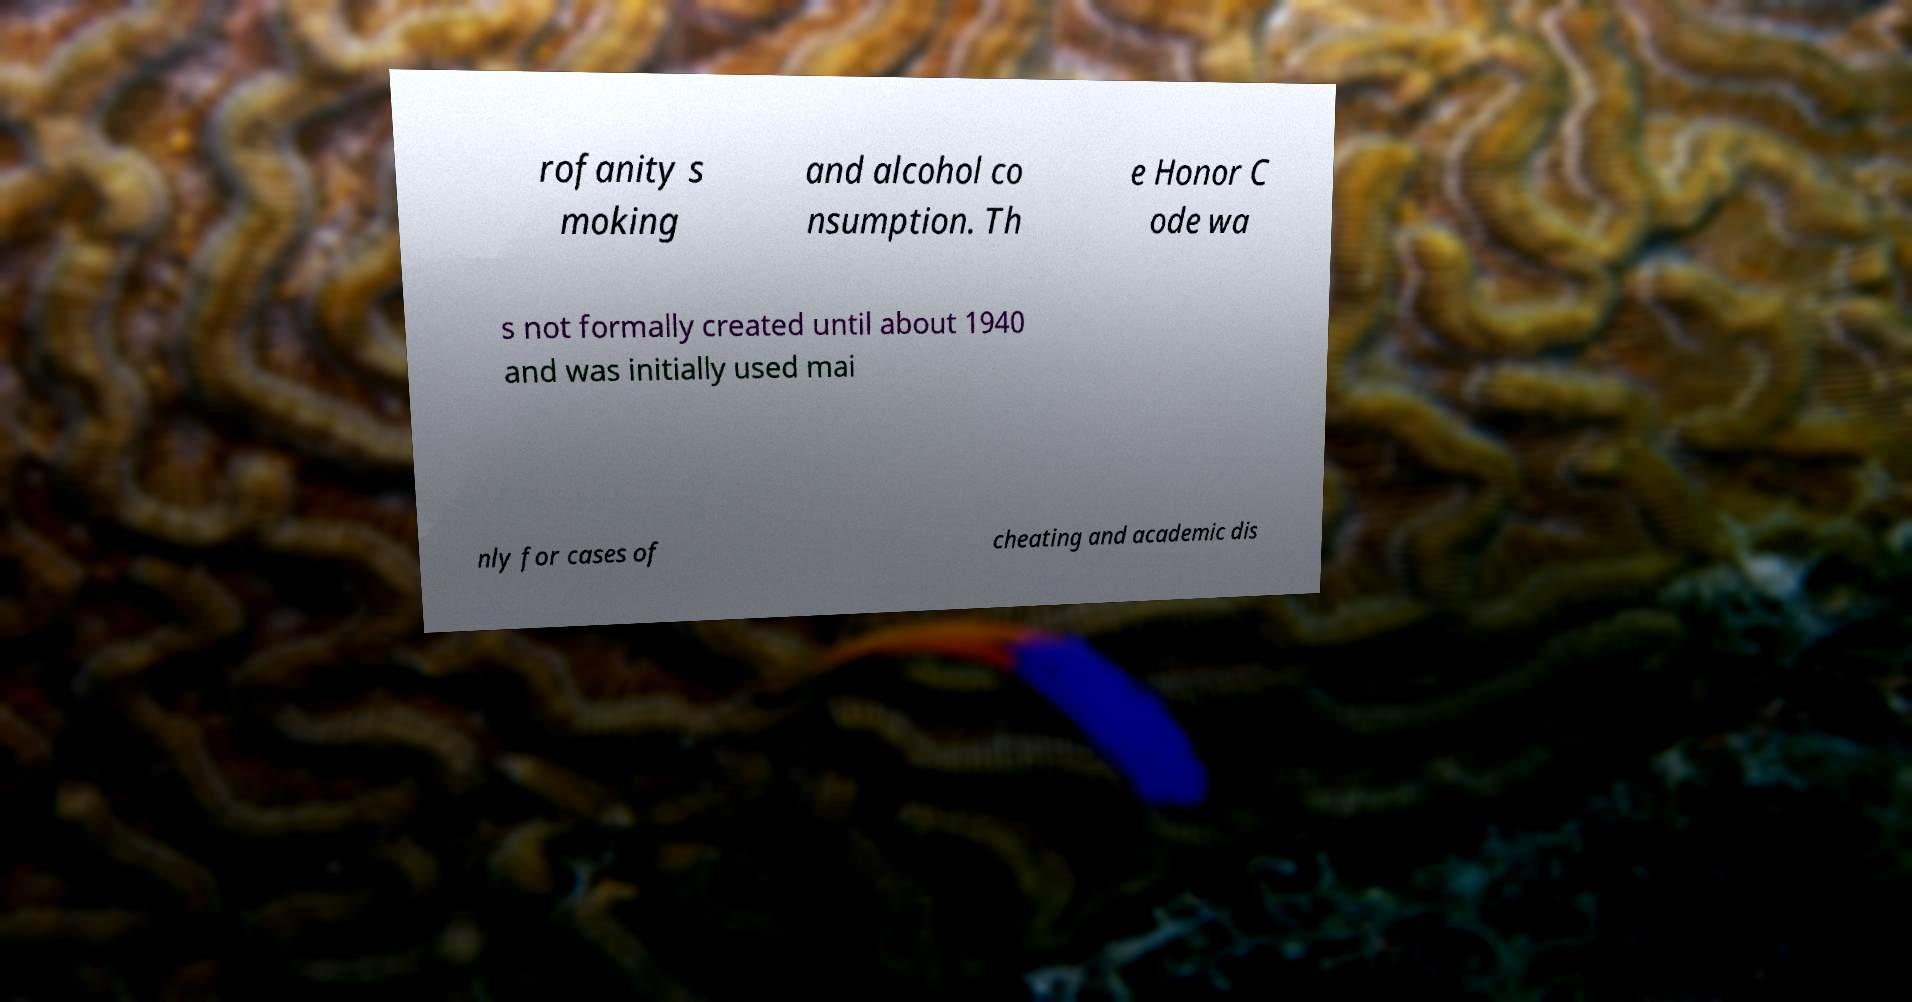For documentation purposes, I need the text within this image transcribed. Could you provide that? rofanity s moking and alcohol co nsumption. Th e Honor C ode wa s not formally created until about 1940 and was initially used mai nly for cases of cheating and academic dis 